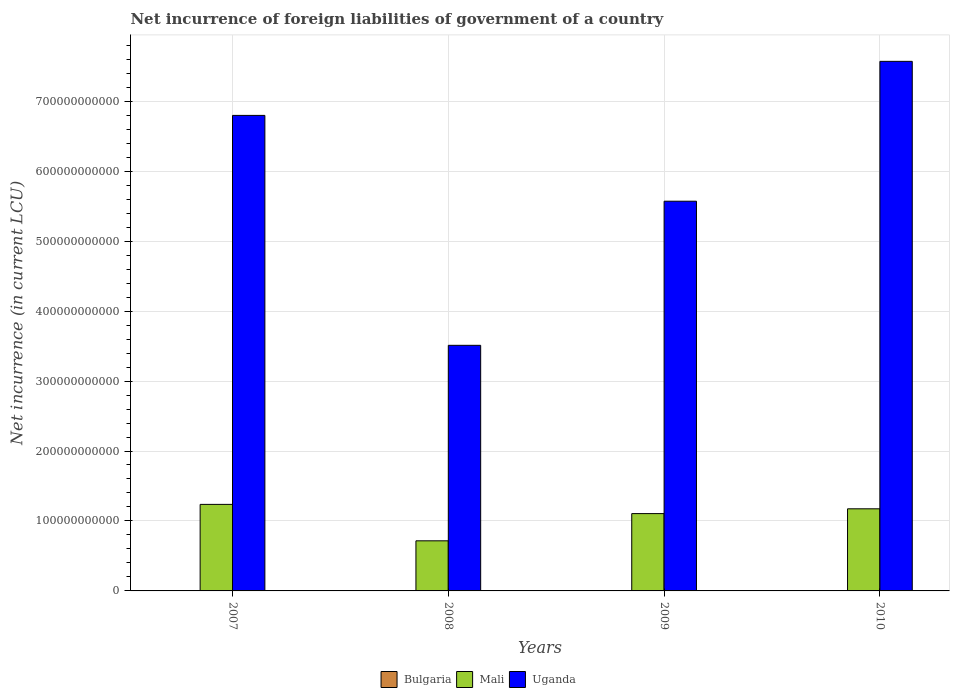How many different coloured bars are there?
Keep it short and to the point. 3. Are the number of bars per tick equal to the number of legend labels?
Your response must be concise. No. How many bars are there on the 4th tick from the left?
Your response must be concise. 2. How many bars are there on the 3rd tick from the right?
Keep it short and to the point. 2. What is the label of the 3rd group of bars from the left?
Make the answer very short. 2009. In how many cases, is the number of bars for a given year not equal to the number of legend labels?
Your answer should be very brief. 3. What is the net incurrence of foreign liabilities in Bulgaria in 2009?
Ensure brevity in your answer.  3.83e+08. Across all years, what is the maximum net incurrence of foreign liabilities in Bulgaria?
Your response must be concise. 3.83e+08. Across all years, what is the minimum net incurrence of foreign liabilities in Bulgaria?
Offer a very short reply. 0. In which year was the net incurrence of foreign liabilities in Uganda maximum?
Make the answer very short. 2010. What is the total net incurrence of foreign liabilities in Bulgaria in the graph?
Give a very brief answer. 3.83e+08. What is the difference between the net incurrence of foreign liabilities in Mali in 2007 and that in 2010?
Offer a terse response. 6.32e+09. What is the difference between the net incurrence of foreign liabilities in Mali in 2008 and the net incurrence of foreign liabilities in Bulgaria in 2010?
Offer a terse response. 7.16e+1. What is the average net incurrence of foreign liabilities in Mali per year?
Provide a succinct answer. 1.06e+11. In the year 2007, what is the difference between the net incurrence of foreign liabilities in Mali and net incurrence of foreign liabilities in Uganda?
Your answer should be very brief. -5.56e+11. In how many years, is the net incurrence of foreign liabilities in Bulgaria greater than 100000000000 LCU?
Your response must be concise. 0. What is the ratio of the net incurrence of foreign liabilities in Mali in 2008 to that in 2010?
Keep it short and to the point. 0.61. What is the difference between the highest and the second highest net incurrence of foreign liabilities in Mali?
Make the answer very short. 6.32e+09. What is the difference between the highest and the lowest net incurrence of foreign liabilities in Bulgaria?
Give a very brief answer. 3.83e+08. Is it the case that in every year, the sum of the net incurrence of foreign liabilities in Bulgaria and net incurrence of foreign liabilities in Uganda is greater than the net incurrence of foreign liabilities in Mali?
Provide a succinct answer. Yes. Are all the bars in the graph horizontal?
Your response must be concise. No. What is the difference between two consecutive major ticks on the Y-axis?
Ensure brevity in your answer.  1.00e+11. Are the values on the major ticks of Y-axis written in scientific E-notation?
Your response must be concise. No. Does the graph contain any zero values?
Your response must be concise. Yes. Does the graph contain grids?
Provide a short and direct response. Yes. How many legend labels are there?
Offer a terse response. 3. What is the title of the graph?
Provide a short and direct response. Net incurrence of foreign liabilities of government of a country. What is the label or title of the Y-axis?
Your answer should be compact. Net incurrence (in current LCU). What is the Net incurrence (in current LCU) in Mali in 2007?
Ensure brevity in your answer.  1.24e+11. What is the Net incurrence (in current LCU) of Uganda in 2007?
Make the answer very short. 6.80e+11. What is the Net incurrence (in current LCU) in Mali in 2008?
Give a very brief answer. 7.16e+1. What is the Net incurrence (in current LCU) of Uganda in 2008?
Give a very brief answer. 3.51e+11. What is the Net incurrence (in current LCU) of Bulgaria in 2009?
Your response must be concise. 3.83e+08. What is the Net incurrence (in current LCU) in Mali in 2009?
Your response must be concise. 1.11e+11. What is the Net incurrence (in current LCU) in Uganda in 2009?
Offer a very short reply. 5.57e+11. What is the Net incurrence (in current LCU) of Mali in 2010?
Your response must be concise. 1.17e+11. What is the Net incurrence (in current LCU) of Uganda in 2010?
Provide a short and direct response. 7.57e+11. Across all years, what is the maximum Net incurrence (in current LCU) of Bulgaria?
Give a very brief answer. 3.83e+08. Across all years, what is the maximum Net incurrence (in current LCU) of Mali?
Offer a terse response. 1.24e+11. Across all years, what is the maximum Net incurrence (in current LCU) of Uganda?
Make the answer very short. 7.57e+11. Across all years, what is the minimum Net incurrence (in current LCU) in Mali?
Make the answer very short. 7.16e+1. Across all years, what is the minimum Net incurrence (in current LCU) in Uganda?
Offer a terse response. 3.51e+11. What is the total Net incurrence (in current LCU) in Bulgaria in the graph?
Give a very brief answer. 3.83e+08. What is the total Net incurrence (in current LCU) in Mali in the graph?
Your response must be concise. 4.23e+11. What is the total Net incurrence (in current LCU) of Uganda in the graph?
Offer a very short reply. 2.34e+12. What is the difference between the Net incurrence (in current LCU) of Mali in 2007 and that in 2008?
Give a very brief answer. 5.21e+1. What is the difference between the Net incurrence (in current LCU) in Uganda in 2007 and that in 2008?
Provide a short and direct response. 3.29e+11. What is the difference between the Net incurrence (in current LCU) in Mali in 2007 and that in 2009?
Offer a terse response. 1.32e+1. What is the difference between the Net incurrence (in current LCU) in Uganda in 2007 and that in 2009?
Provide a succinct answer. 1.23e+11. What is the difference between the Net incurrence (in current LCU) in Mali in 2007 and that in 2010?
Offer a terse response. 6.32e+09. What is the difference between the Net incurrence (in current LCU) of Uganda in 2007 and that in 2010?
Give a very brief answer. -7.73e+1. What is the difference between the Net incurrence (in current LCU) of Mali in 2008 and that in 2009?
Your answer should be very brief. -3.89e+1. What is the difference between the Net incurrence (in current LCU) in Uganda in 2008 and that in 2009?
Your answer should be very brief. -2.06e+11. What is the difference between the Net incurrence (in current LCU) in Mali in 2008 and that in 2010?
Provide a succinct answer. -4.58e+1. What is the difference between the Net incurrence (in current LCU) of Uganda in 2008 and that in 2010?
Make the answer very short. -4.06e+11. What is the difference between the Net incurrence (in current LCU) of Mali in 2009 and that in 2010?
Provide a short and direct response. -6.86e+09. What is the difference between the Net incurrence (in current LCU) of Uganda in 2009 and that in 2010?
Ensure brevity in your answer.  -2.00e+11. What is the difference between the Net incurrence (in current LCU) in Mali in 2007 and the Net incurrence (in current LCU) in Uganda in 2008?
Provide a short and direct response. -2.27e+11. What is the difference between the Net incurrence (in current LCU) in Mali in 2007 and the Net incurrence (in current LCU) in Uganda in 2009?
Keep it short and to the point. -4.33e+11. What is the difference between the Net incurrence (in current LCU) in Mali in 2007 and the Net incurrence (in current LCU) in Uganda in 2010?
Give a very brief answer. -6.33e+11. What is the difference between the Net incurrence (in current LCU) in Mali in 2008 and the Net incurrence (in current LCU) in Uganda in 2009?
Offer a very short reply. -4.85e+11. What is the difference between the Net incurrence (in current LCU) in Mali in 2008 and the Net incurrence (in current LCU) in Uganda in 2010?
Give a very brief answer. -6.85e+11. What is the difference between the Net incurrence (in current LCU) of Bulgaria in 2009 and the Net incurrence (in current LCU) of Mali in 2010?
Your answer should be compact. -1.17e+11. What is the difference between the Net incurrence (in current LCU) of Bulgaria in 2009 and the Net incurrence (in current LCU) of Uganda in 2010?
Provide a short and direct response. -7.57e+11. What is the difference between the Net incurrence (in current LCU) in Mali in 2009 and the Net incurrence (in current LCU) in Uganda in 2010?
Provide a succinct answer. -6.46e+11. What is the average Net incurrence (in current LCU) of Bulgaria per year?
Your answer should be very brief. 9.58e+07. What is the average Net incurrence (in current LCU) of Mali per year?
Give a very brief answer. 1.06e+11. What is the average Net incurrence (in current LCU) of Uganda per year?
Your response must be concise. 5.86e+11. In the year 2007, what is the difference between the Net incurrence (in current LCU) in Mali and Net incurrence (in current LCU) in Uganda?
Keep it short and to the point. -5.56e+11. In the year 2008, what is the difference between the Net incurrence (in current LCU) in Mali and Net incurrence (in current LCU) in Uganda?
Your answer should be very brief. -2.79e+11. In the year 2009, what is the difference between the Net incurrence (in current LCU) in Bulgaria and Net incurrence (in current LCU) in Mali?
Provide a short and direct response. -1.10e+11. In the year 2009, what is the difference between the Net incurrence (in current LCU) of Bulgaria and Net incurrence (in current LCU) of Uganda?
Give a very brief answer. -5.57e+11. In the year 2009, what is the difference between the Net incurrence (in current LCU) in Mali and Net incurrence (in current LCU) in Uganda?
Your response must be concise. -4.47e+11. In the year 2010, what is the difference between the Net incurrence (in current LCU) in Mali and Net incurrence (in current LCU) in Uganda?
Keep it short and to the point. -6.40e+11. What is the ratio of the Net incurrence (in current LCU) of Mali in 2007 to that in 2008?
Make the answer very short. 1.73. What is the ratio of the Net incurrence (in current LCU) in Uganda in 2007 to that in 2008?
Your answer should be very brief. 1.94. What is the ratio of the Net incurrence (in current LCU) in Mali in 2007 to that in 2009?
Make the answer very short. 1.12. What is the ratio of the Net incurrence (in current LCU) of Uganda in 2007 to that in 2009?
Make the answer very short. 1.22. What is the ratio of the Net incurrence (in current LCU) of Mali in 2007 to that in 2010?
Keep it short and to the point. 1.05. What is the ratio of the Net incurrence (in current LCU) of Uganda in 2007 to that in 2010?
Offer a very short reply. 0.9. What is the ratio of the Net incurrence (in current LCU) of Mali in 2008 to that in 2009?
Your answer should be compact. 0.65. What is the ratio of the Net incurrence (in current LCU) in Uganda in 2008 to that in 2009?
Keep it short and to the point. 0.63. What is the ratio of the Net incurrence (in current LCU) in Mali in 2008 to that in 2010?
Your answer should be compact. 0.61. What is the ratio of the Net incurrence (in current LCU) of Uganda in 2008 to that in 2010?
Keep it short and to the point. 0.46. What is the ratio of the Net incurrence (in current LCU) in Mali in 2009 to that in 2010?
Your answer should be compact. 0.94. What is the ratio of the Net incurrence (in current LCU) in Uganda in 2009 to that in 2010?
Ensure brevity in your answer.  0.74. What is the difference between the highest and the second highest Net incurrence (in current LCU) in Mali?
Your answer should be compact. 6.32e+09. What is the difference between the highest and the second highest Net incurrence (in current LCU) of Uganda?
Offer a very short reply. 7.73e+1. What is the difference between the highest and the lowest Net incurrence (in current LCU) in Bulgaria?
Give a very brief answer. 3.83e+08. What is the difference between the highest and the lowest Net incurrence (in current LCU) of Mali?
Your response must be concise. 5.21e+1. What is the difference between the highest and the lowest Net incurrence (in current LCU) of Uganda?
Provide a short and direct response. 4.06e+11. 